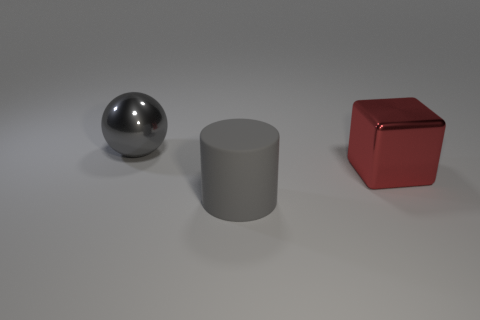What shape is the thing that is made of the same material as the ball?
Your answer should be compact. Cube. Is the number of big gray rubber cylinders less than the number of big blue balls?
Make the answer very short. No. The large thing that is behind the cylinder and in front of the big metallic sphere is made of what material?
Your response must be concise. Metal. What size is the gray object that is in front of the large gray thing that is left of the thing that is in front of the big metal cube?
Provide a short and direct response. Large. There is a gray shiny object; does it have the same shape as the gray thing that is in front of the large red object?
Provide a succinct answer. No. What number of metal things are both to the left of the shiny block and in front of the gray shiny thing?
Give a very brief answer. 0. How many green things are either large matte cylinders or shiny things?
Your answer should be very brief. 0. Does the metal thing that is behind the red block have the same color as the big thing in front of the metal block?
Ensure brevity in your answer.  Yes. There is a metal object that is in front of the object on the left side of the gray object that is on the right side of the sphere; what is its color?
Offer a terse response. Red. There is a large thing behind the red metal object; is there a thing that is behind it?
Your answer should be very brief. No. 